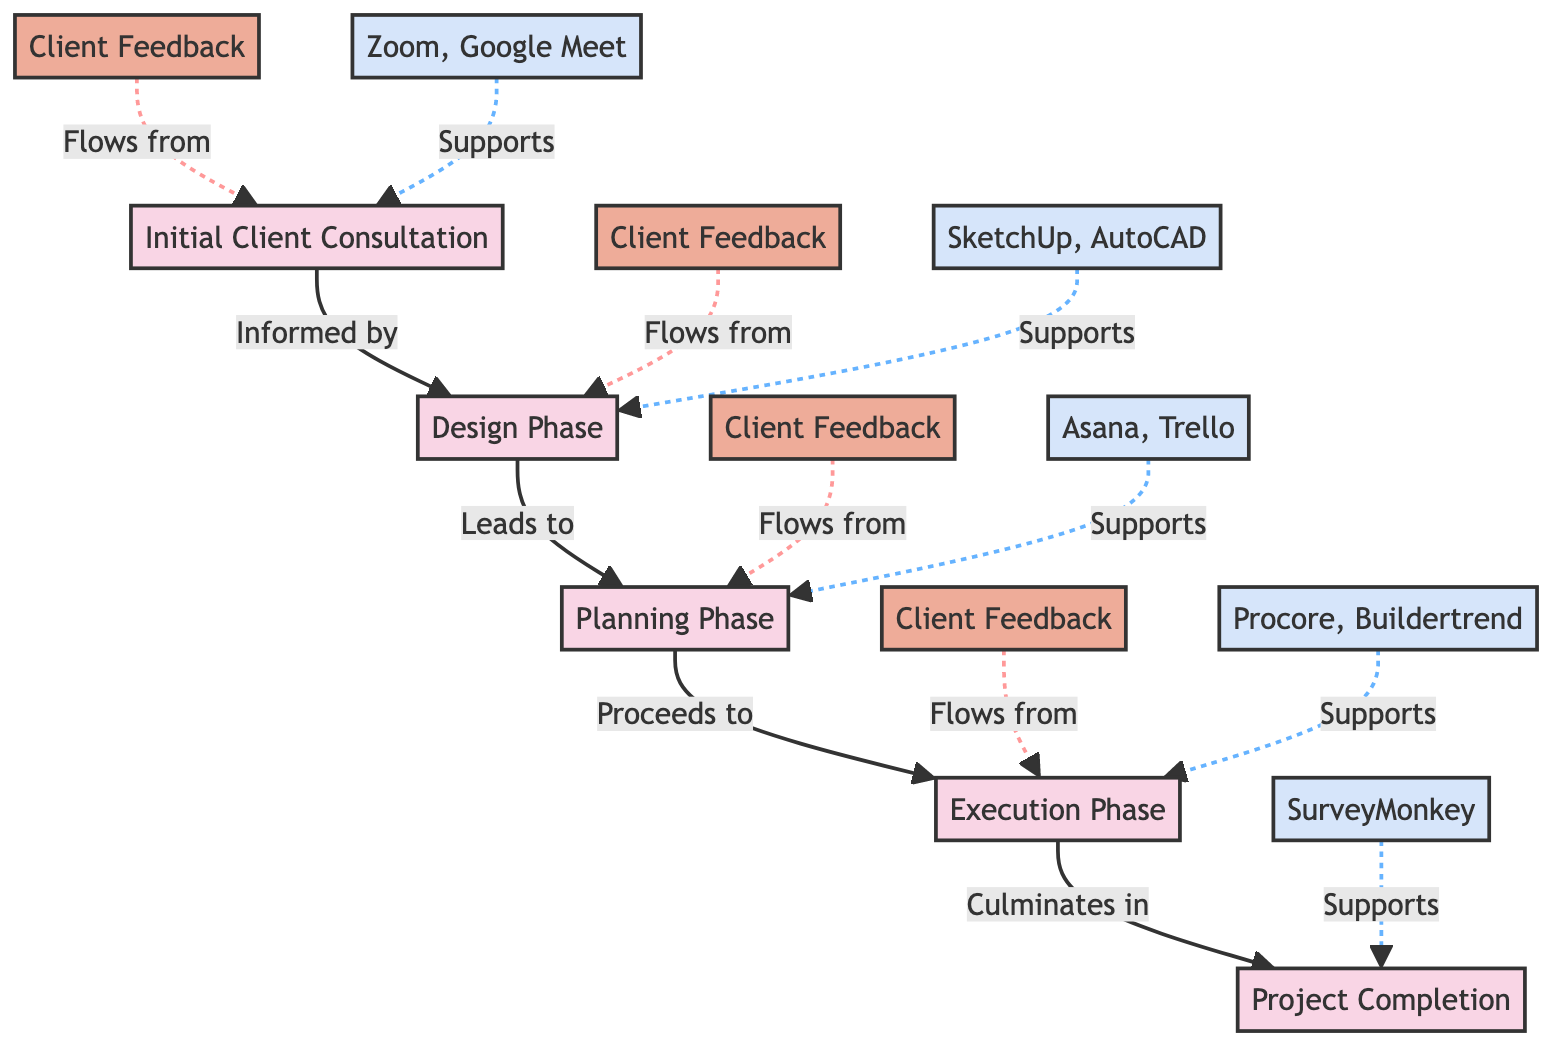What is the first phase in the workflow? The workflow starts with the "Initial Client Consultation," which is the first node in the sequence of phases.
Answer: Initial Client Consultation How many client feedback points are there? The diagram shows four distinct client feedback points corresponding to each project phase, making the total feedback points four.
Answer: 4 What does the execution phase lead to? According to the diagram, the "Execution Phase" flows to the "Project Completion," indicating that completion is the next step after execution.
Answer: Project Completion Which collaboration tool supports the design phase? The diagram lists "SketchUp, AutoCAD" as the collaboration tools used in the "Design Phase," making this the correct answer.
Answer: SketchUp, AutoCAD What is the relationship between the planning phase and execution phase? The diagram indicates that the "Planning Phase" proceeds directly to the "Execution Phase," depicting an ordered workflow.
Answer: Proceeds to What type of collaboration tools support the completion phase? For the "Project Completion" phase, the diagram identifies "SurveyMonkey" as the collaboration tool used, which specifically supports feedback collection.
Answer: SurveyMonkey Is there any client feedback after the initial consultation? Yes, the diagram indicates that there is a client feedback point that flows from the "Initial Client Consultation," thus confirming the existence of feedback at this stage.
Answer: Yes How many phases are depicted in the diagram? The diagram contains five phases, explicitly listed from "Initial Client Consultation" to "Project Completion." Therefore, the total number of phases is five.
Answer: 5 What are the collaboration tools listed for the execution phase? The collaboration tools associated with the execution phase are "Procore, Buildertrend," according to the diagram.
Answer: Procore, Buildertrend Which node is connected to the client feedback for the design phase? The "Client Feedback" node related to feedback for the "Design Phase" shows a specific connection indicating feedback flows from the design phase.
Answer: Client Feedback 